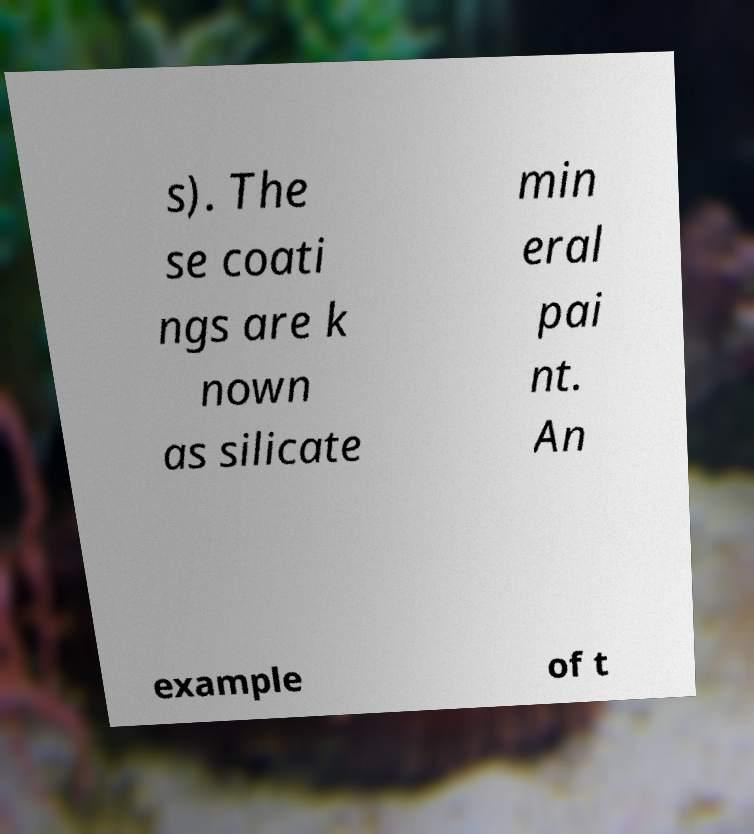Can you accurately transcribe the text from the provided image for me? s). The se coati ngs are k nown as silicate min eral pai nt. An example of t 